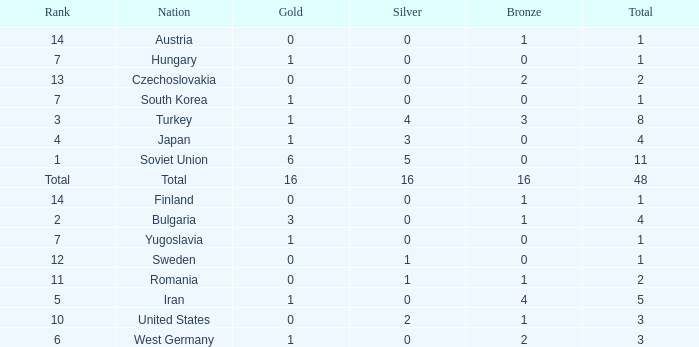How many total golds do teams have when the total medals is less than 1? None. 